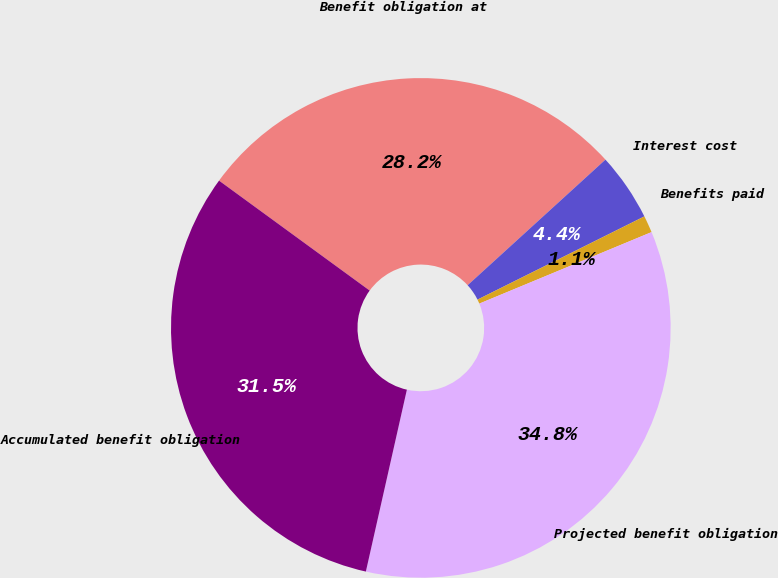Convert chart to OTSL. <chart><loc_0><loc_0><loc_500><loc_500><pie_chart><fcel>Benefit obligation at<fcel>Interest cost<fcel>Benefits paid<fcel>Projected benefit obligation<fcel>Accumulated benefit obligation<nl><fcel>28.2%<fcel>4.4%<fcel>1.1%<fcel>34.79%<fcel>31.5%<nl></chart> 